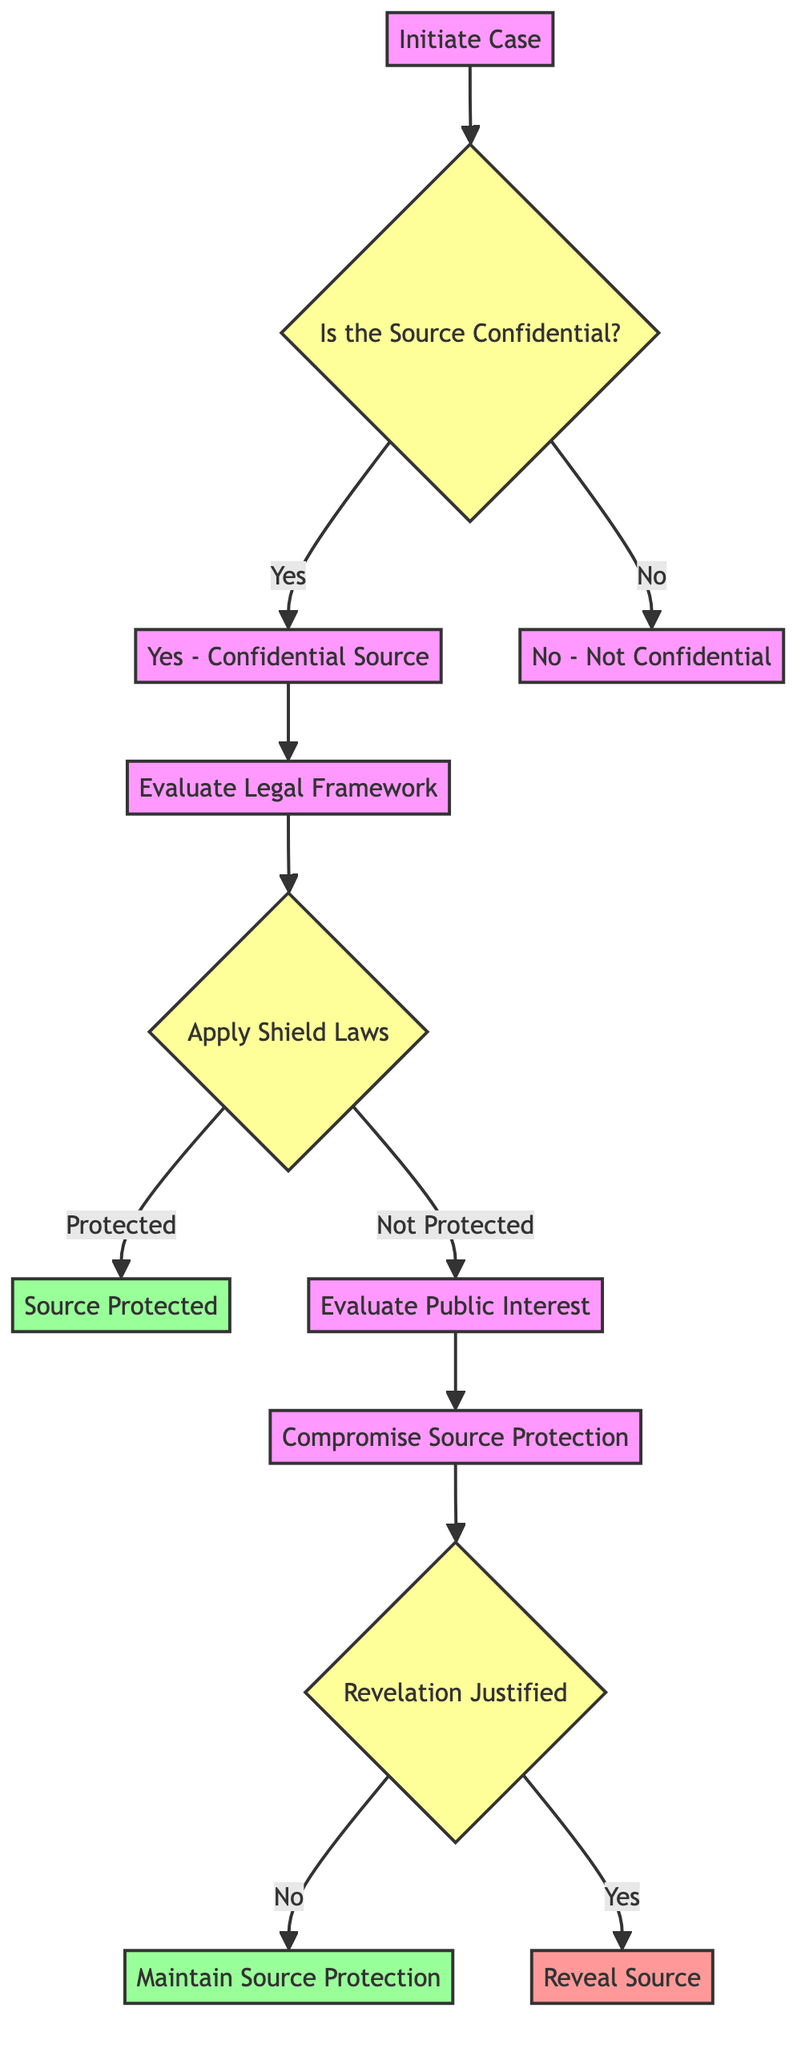What is the first step in the decision pathway? The first step in the pathway is represented by the node labeled "Initiate Case," which indicates that a case involving a journalist's source protection is initiated.
Answer: Initiate Case How many nodes are there in total? Counting the nodes listed in the diagram, there are a total of 12 nodes present, each corresponding to a specific step in the decision pathway.
Answer: 12 What happens if the source is confidential? If the source is confidential, the pathway moves from the decision node "Is the Source Confidential?" (node 2) to the node labeled "Yes - Confidential Source" (node 3), indicating this determination.
Answer: Yes - Confidential Source What is the outcome if shield laws protect the source? If shield laws protect the source, the pathway leads to the node "Source Protected," which confirms that legal protection is granted under media law, thus ensuring confidentiality.
Answer: Source Protected What happens after evaluating public interest if the source protection is compromised? If the source protection is compromised, the pathway continues to the decision node "Revelation Justified" (node 10) to assess whether revealing the source is justified based on public interest considerations.
Answer: Revelation Justified What is the action taken if the revelation of the source is not justified? If the revelation of the source is determined to be not justified, the decision leads to the action "Maintain Source Protection," which means continuing to protect the source's confidentiality.
Answer: Maintain Source Protection What two outcomes can occur after applying shield laws? After applying shield laws, the outcomes can either be "Source Protected," meaning the source is granted protection, or lead to "Evaluate Public Interest," if the source is not protected under those laws.
Answer: Source Protected and Evaluate Public Interest Which node indicates a decision point regarding the justification of revealing the source? The node labeled "Revelation Justified" (node 10) represents a decision point where it is determined whether the public interest justifies revealing the source or not.
Answer: Revelation Justified What is the label of the node that deals with evaluating the legal framework? The node concerned with evaluating the legal framework is labeled "Evaluate Legal Framework," which involves assessing the relevant media laws and case precedents related to source protection.
Answer: Evaluate Legal Framework 